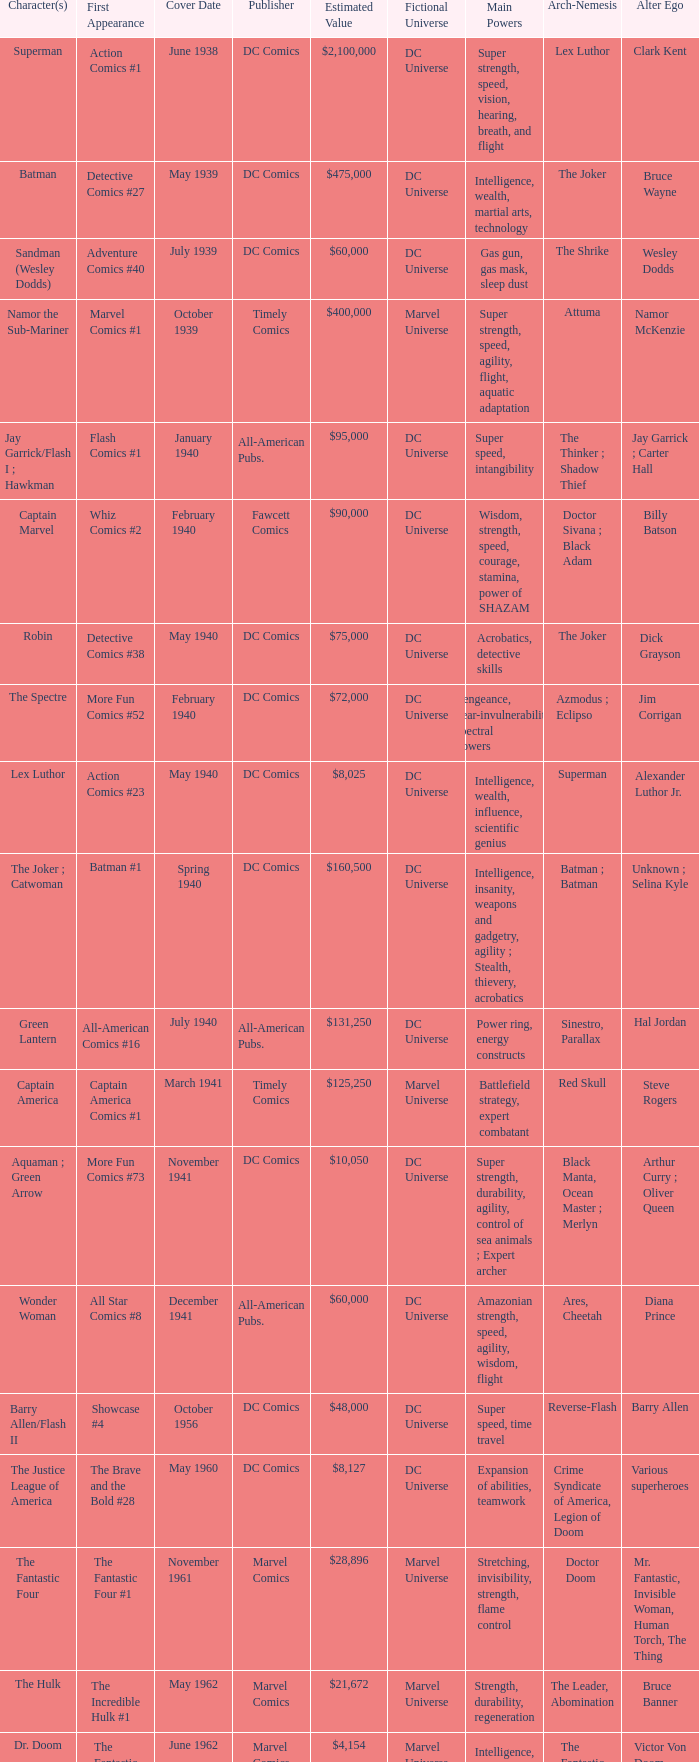I'm looking to parse the entire table for insights. Could you assist me with that? {'header': ['Character(s)', 'First Appearance', 'Cover Date', 'Publisher', 'Estimated Value', 'Fictional Universe', 'Main Powers', 'Arch-Nemesis', 'Alter Ego'], 'rows': [['Superman', 'Action Comics #1', 'June 1938', 'DC Comics', '$2,100,000', 'DC Universe', 'Super strength, speed, vision, hearing, breath, and flight', 'Lex Luthor', 'Clark Kent'], ['Batman', 'Detective Comics #27', 'May 1939', 'DC Comics', '$475,000', 'DC Universe', 'Intelligence, wealth, martial arts, technology', 'The Joker', 'Bruce Wayne'], ['Sandman (Wesley Dodds)', 'Adventure Comics #40', 'July 1939', 'DC Comics', '$60,000', 'DC Universe', 'Gas gun, gas mask, sleep dust', 'The Shrike', 'Wesley Dodds'], ['Namor the Sub-Mariner', 'Marvel Comics #1', 'October 1939', 'Timely Comics', '$400,000', 'Marvel Universe', 'Super strength, speed, agility, flight, aquatic adaptation', 'Attuma', 'Namor McKenzie'], ['Jay Garrick/Flash I ; Hawkman', 'Flash Comics #1', 'January 1940', 'All-American Pubs.', '$95,000', 'DC Universe', 'Super speed, intangibility', 'The Thinker ; Shadow Thief', 'Jay Garrick ; Carter Hall'], ['Captain Marvel', 'Whiz Comics #2', 'February 1940', 'Fawcett Comics', '$90,000', 'DC Universe', 'Wisdom, strength, speed, courage, stamina, power of SHAZAM', 'Doctor Sivana ; Black Adam', 'Billy Batson'], ['Robin', 'Detective Comics #38', 'May 1940', 'DC Comics', '$75,000', 'DC Universe', 'Acrobatics, detective skills', 'The Joker', 'Dick Grayson'], ['The Spectre', 'More Fun Comics #52', 'February 1940', 'DC Comics', '$72,000', 'DC Universe', 'Vengeance, near-invulnerability, spectral powers', 'Azmodus ; Eclipso', 'Jim Corrigan'], ['Lex Luthor', 'Action Comics #23', 'May 1940', 'DC Comics', '$8,025', 'DC Universe', 'Intelligence, wealth, influence, scientific genius', 'Superman', 'Alexander Luthor Jr.'], ['The Joker ; Catwoman', 'Batman #1', 'Spring 1940', 'DC Comics', '$160,500', 'DC Universe', 'Intelligence, insanity, weapons and gadgetry, agility ; Stealth, thievery, acrobatics', 'Batman ; Batman', 'Unknown ; Selina Kyle'], ['Green Lantern', 'All-American Comics #16', 'July 1940', 'All-American Pubs.', '$131,250', 'DC Universe', 'Power ring, energy constructs', 'Sinestro, Parallax', 'Hal Jordan'], ['Captain America', 'Captain America Comics #1', 'March 1941', 'Timely Comics', '$125,250', 'Marvel Universe', 'Battlefield strategy, expert combatant', 'Red Skull', 'Steve Rogers'], ['Aquaman ; Green Arrow', 'More Fun Comics #73', 'November 1941', 'DC Comics', '$10,050', 'DC Universe', 'Super strength, durability, agility, control of sea animals ; Expert archer', 'Black Manta, Ocean Master ; Merlyn', 'Arthur Curry ; Oliver Queen'], ['Wonder Woman', 'All Star Comics #8', 'December 1941', 'All-American Pubs.', '$60,000', 'DC Universe', 'Amazonian strength, speed, agility, wisdom, flight', 'Ares, Cheetah', 'Diana Prince'], ['Barry Allen/Flash II', 'Showcase #4', 'October 1956', 'DC Comics', '$48,000', 'DC Universe', 'Super speed, time travel', 'Reverse-Flash', 'Barry Allen'], ['The Justice League of America', 'The Brave and the Bold #28', 'May 1960', 'DC Comics', '$8,127', 'DC Universe', 'Expansion of abilities, teamwork', 'Crime Syndicate of America, Legion of Doom', 'Various superheroes'], ['The Fantastic Four', 'The Fantastic Four #1', 'November 1961', 'Marvel Comics', '$28,896', 'Marvel Universe', 'Stretching, invisibility, strength, flame control', 'Doctor Doom', 'Mr. Fantastic, Invisible Woman, Human Torch, The Thing'], ['The Hulk', 'The Incredible Hulk #1', 'May 1962', 'Marvel Comics', '$21,672', 'Marvel Universe', 'Strength, durability, regeneration', 'The Leader, Abomination', 'Bruce Banner'], ['Dr. Doom', 'The Fantastic Four #5', 'June 1962', 'Marvel Comics', '$4,154', 'Marvel Universe', 'Intelligence, sorcery, armor', 'The Fantastic Four', 'Victor Von Doom'], ['Spider-Man', 'Amazing Fantasy #15', 'August 1962', 'Marvel Comics', '$45,150', 'Marvel Universe', 'Wall-crawling, web-slinging, spider-sense', 'Green Goblin', 'Peter Parker'], ['Iron Man', 'Tales of Suspense #39', 'March 1963', 'Marvel Comics', '$3,837', 'Marvel Universe', 'Genius-level intellect, advanced technology, strength', 'Mandarin', 'Tony Stark'], ['Doctor Strange', 'Strange Tales #110', 'July 1963', 'Marvel Comics', '$3,500', 'Marvel Universe', 'Magic, mystical artifacts', 'Dormammu', 'Stephen Strange'], ['X-Men ; Magneto', 'X-Men #1', 'September 1963', 'Marvel Comics', '$13,545', 'Marvel Universe', 'Mutant abilities, combat training', 'Magneto', 'Various mutants'], ['The Avengers', 'The Avengers #1', 'September 1963', 'Marvel Comics', '$5,148', 'Marvel Universe', 'A team of superheroes with various powers and abilities', 'Loki', 'Various superheroes'], ['Daredevil', 'Daredevil #1', 'April 1964', 'Marvel Comics', '$3,160', 'Marvel Universe', 'Radar sense, heightened senses, martial arts', 'Kingpin', 'Matt Murdock'], ['Teen Titans', 'The Brave and the Bold #54', 'July 1964', 'DC Comics', '$415', 'DC Universe', 'Enhanced abilities, teamwork, sidekicks', 'Deathstroke', 'Various teenage superheroes'], ['The Punisher', 'The Amazing Spider-Man #129', 'February 1974', 'Marvel Comics', '$918', 'Marvel Universe', 'Expert marksman, skilled combatant', 'Jigsaw', 'Frank Castle'], ['Wolverine', 'The Incredible Hulk #180', 'October 1974', 'Marvel Comics', '$350', 'Marvel Universe', 'Adamantium claws, accelerated healing, animal senses', 'Sabretooth', 'James "Logan" Howlett'], ['Teenage Mutant Ninja Turtles', 'Teenage Mutant Ninja Turtles #1', 'May 1984', 'Mirage Studios', '$2,400', 'Mirage Comics', 'Ninjitsu, strength, speed, stealth', 'Shredder', 'Leonardo, Raphael, Michelangelo, Donatello']]} Which character first appeared in Amazing Fantasy #15? Spider-Man. 